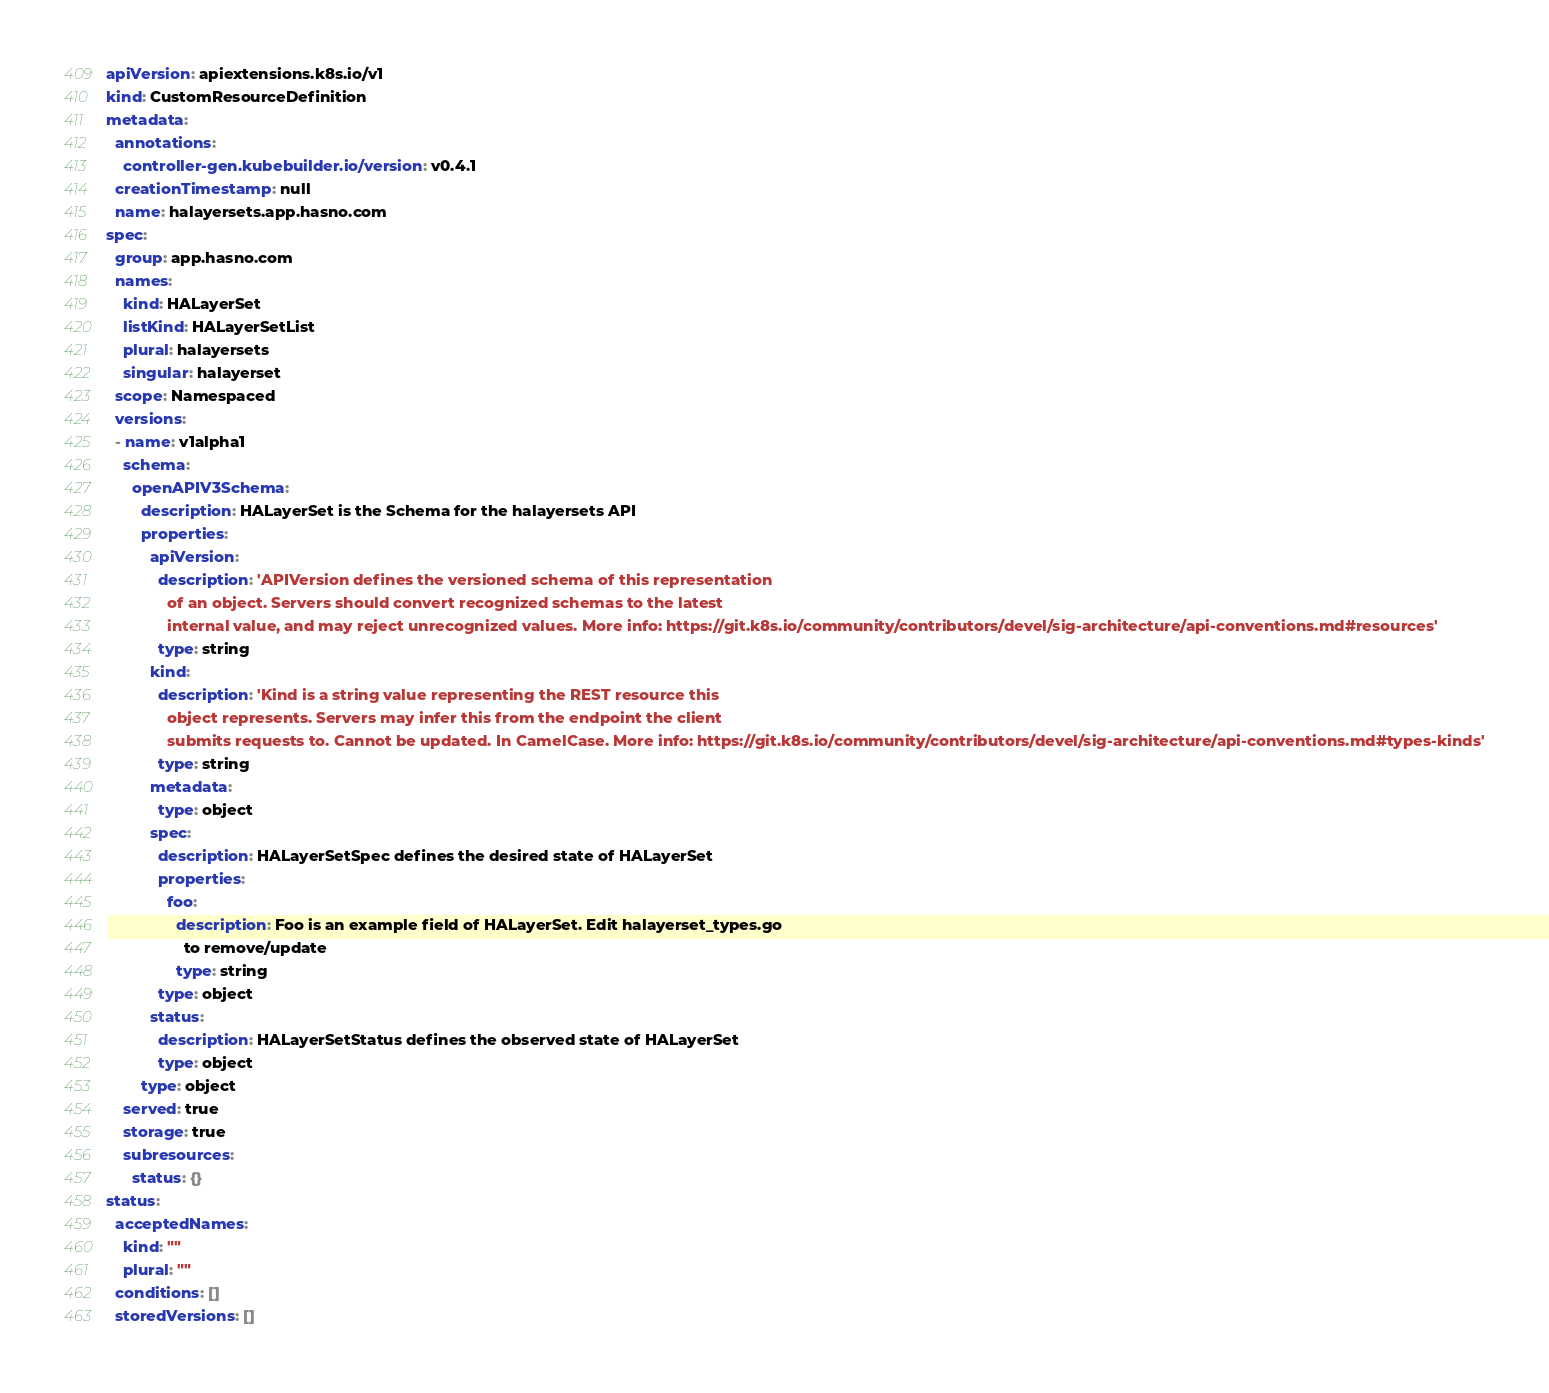<code> <loc_0><loc_0><loc_500><loc_500><_YAML_>apiVersion: apiextensions.k8s.io/v1
kind: CustomResourceDefinition
metadata:
  annotations:
    controller-gen.kubebuilder.io/version: v0.4.1
  creationTimestamp: null
  name: halayersets.app.hasno.com
spec:
  group: app.hasno.com
  names:
    kind: HALayerSet
    listKind: HALayerSetList
    plural: halayersets
    singular: halayerset
  scope: Namespaced
  versions:
  - name: v1alpha1
    schema:
      openAPIV3Schema:
        description: HALayerSet is the Schema for the halayersets API
        properties:
          apiVersion:
            description: 'APIVersion defines the versioned schema of this representation
              of an object. Servers should convert recognized schemas to the latest
              internal value, and may reject unrecognized values. More info: https://git.k8s.io/community/contributors/devel/sig-architecture/api-conventions.md#resources'
            type: string
          kind:
            description: 'Kind is a string value representing the REST resource this
              object represents. Servers may infer this from the endpoint the client
              submits requests to. Cannot be updated. In CamelCase. More info: https://git.k8s.io/community/contributors/devel/sig-architecture/api-conventions.md#types-kinds'
            type: string
          metadata:
            type: object
          spec:
            description: HALayerSetSpec defines the desired state of HALayerSet
            properties:
              foo:
                description: Foo is an example field of HALayerSet. Edit halayerset_types.go
                  to remove/update
                type: string
            type: object
          status:
            description: HALayerSetStatus defines the observed state of HALayerSet
            type: object
        type: object
    served: true
    storage: true
    subresources:
      status: {}
status:
  acceptedNames:
    kind: ""
    plural: ""
  conditions: []
  storedVersions: []
</code> 